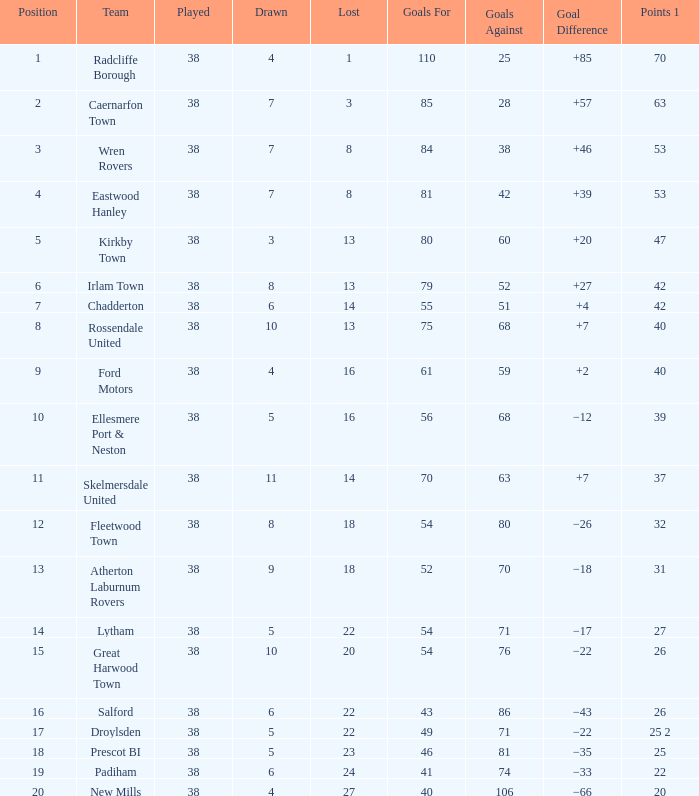How much Drawn has Goals Against larger than 74, and a Lost smaller than 20, and a Played larger than 38? 0.0. 